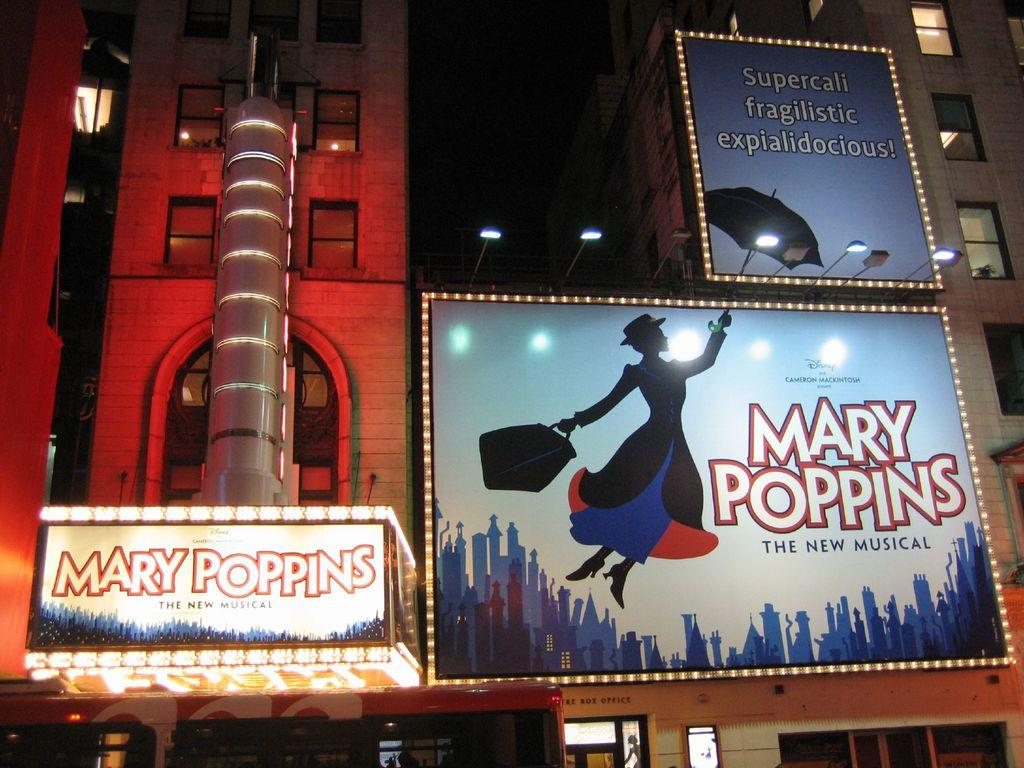<image>
Present a compact description of the photo's key features. Three lit up billboards for Mary Poppins, the new musical. 